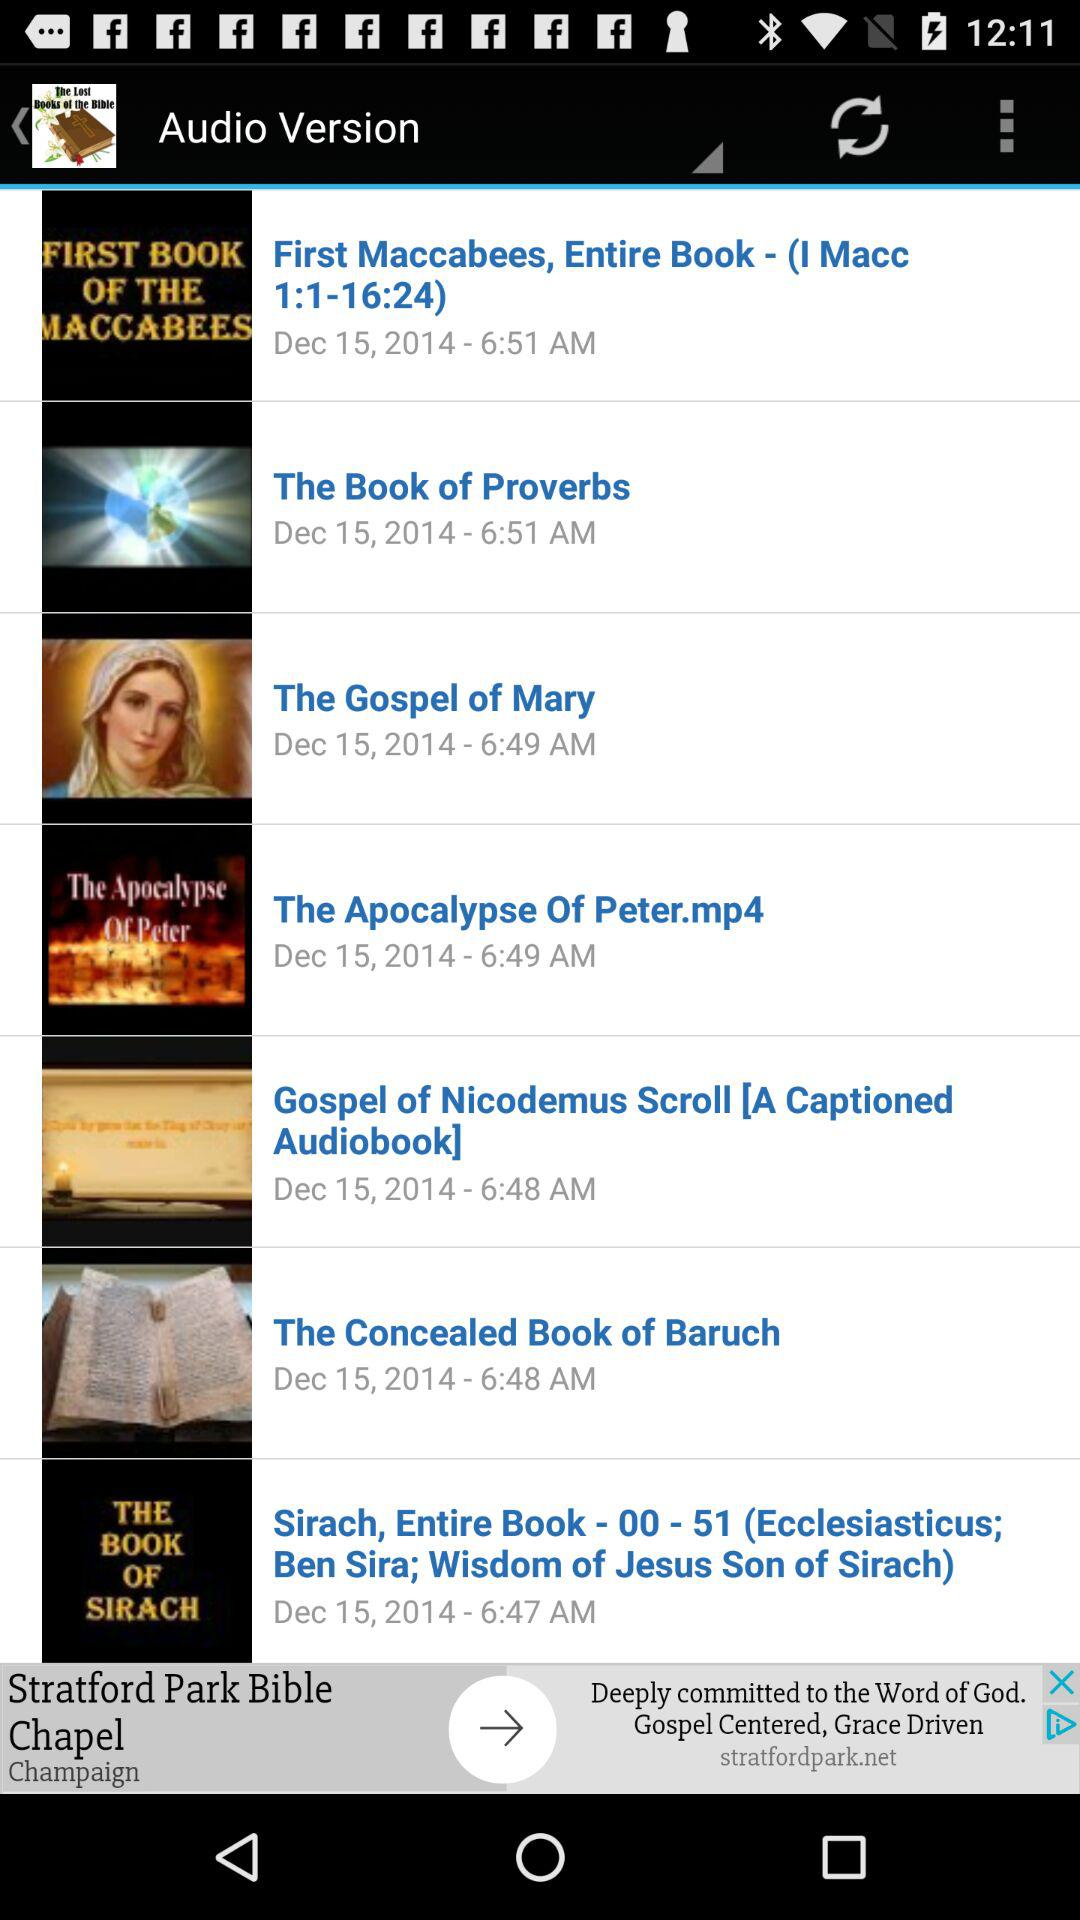What is the posted date of "The Book of Proverbs"? The posted date is December 15, 2014. 